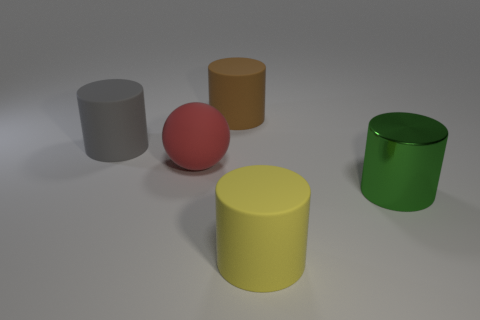There is a matte cylinder on the right side of the cylinder that is behind the cylinder that is left of the large brown rubber cylinder; what is its color?
Provide a short and direct response. Yellow. How many other objects are there of the same shape as the large brown matte object?
Provide a short and direct response. 3. Is the color of the metallic object the same as the big matte ball?
Give a very brief answer. No. What number of objects are tiny shiny balls or big metal cylinders that are in front of the gray matte cylinder?
Offer a terse response. 1. Are there any red balls of the same size as the brown rubber object?
Provide a succinct answer. Yes. Is the red sphere made of the same material as the brown cylinder?
Your answer should be very brief. Yes. How many objects are large purple spheres or green cylinders?
Offer a terse response. 1. What is the size of the red sphere?
Ensure brevity in your answer.  Large. Is the number of large gray objects less than the number of tiny brown rubber cylinders?
Ensure brevity in your answer.  No. Do the cylinder that is on the left side of the brown thing and the large metal thing have the same color?
Keep it short and to the point. No. 